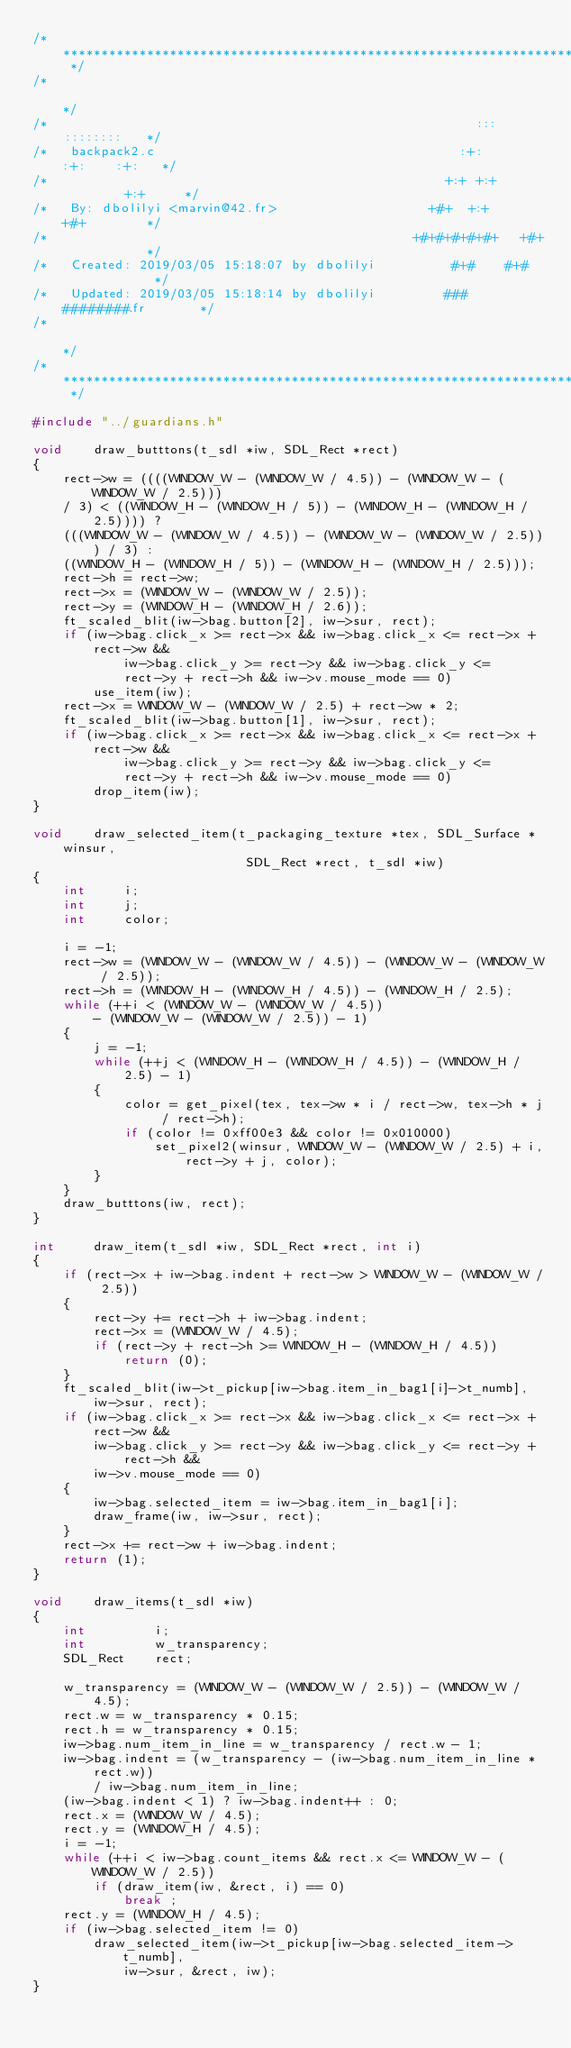<code> <loc_0><loc_0><loc_500><loc_500><_C_>/* ************************************************************************** */
/*                                                                            */
/*                                                        :::      ::::::::   */
/*   backpack2.c                                        :+:      :+:    :+:   */
/*                                                    +:+ +:+         +:+     */
/*   By: dbolilyi <marvin@42.fr>                    +#+  +:+       +#+        */
/*                                                +#+#+#+#+#+   +#+           */
/*   Created: 2019/03/05 15:18:07 by dbolilyi          #+#    #+#             */
/*   Updated: 2019/03/05 15:18:14 by dbolilyi         ###   ########.fr       */
/*                                                                            */
/* ************************************************************************** */

#include "../guardians.h"

void	draw_butttons(t_sdl *iw, SDL_Rect *rect)
{
	rect->w = ((((WINDOW_W - (WINDOW_W / 4.5)) - (WINDOW_W - (WINDOW_W / 2.5)))
	/ 3) < ((WINDOW_H - (WINDOW_H / 5)) - (WINDOW_H - (WINDOW_H / 2.5)))) ?
	(((WINDOW_W - (WINDOW_W / 4.5)) - (WINDOW_W - (WINDOW_W / 2.5))) / 3) :
	((WINDOW_H - (WINDOW_H / 5)) - (WINDOW_H - (WINDOW_H / 2.5)));
	rect->h = rect->w;
	rect->x = (WINDOW_W - (WINDOW_W / 2.5));
	rect->y = (WINDOW_H - (WINDOW_H / 2.6));
	ft_scaled_blit(iw->bag.button[2], iw->sur, rect);
	if (iw->bag.click_x >= rect->x && iw->bag.click_x <= rect->x + rect->w &&
			iw->bag.click_y >= rect->y && iw->bag.click_y <=
			rect->y + rect->h && iw->v.mouse_mode == 0)
		use_item(iw);
	rect->x = WINDOW_W - (WINDOW_W / 2.5) + rect->w * 2;
	ft_scaled_blit(iw->bag.button[1], iw->sur, rect);
	if (iw->bag.click_x >= rect->x && iw->bag.click_x <= rect->x + rect->w &&
			iw->bag.click_y >= rect->y && iw->bag.click_y <=
			rect->y + rect->h && iw->v.mouse_mode == 0)
		drop_item(iw);
}

void	draw_selected_item(t_packaging_texture *tex, SDL_Surface *winsur,
							SDL_Rect *rect, t_sdl *iw)
{
	int		i;
	int		j;
	int		color;

	i = -1;
	rect->w = (WINDOW_W - (WINDOW_W / 4.5)) - (WINDOW_W - (WINDOW_W / 2.5));
	rect->h = (WINDOW_H - (WINDOW_H / 4.5)) - (WINDOW_H / 2.5);
	while (++i < (WINDOW_W - (WINDOW_W / 4.5))
		- (WINDOW_W - (WINDOW_W / 2.5)) - 1)
	{
		j = -1;
		while (++j < (WINDOW_H - (WINDOW_H / 4.5)) - (WINDOW_H / 2.5) - 1)
		{
			color = get_pixel(tex, tex->w * i / rect->w, tex->h * j / rect->h);
			if (color != 0xff00e3 && color != 0x010000)
				set_pixel2(winsur, WINDOW_W - (WINDOW_W / 2.5) + i,
					rect->y + j, color);
		}
	}
	draw_butttons(iw, rect);
}

int		draw_item(t_sdl *iw, SDL_Rect *rect, int i)
{
	if (rect->x + iw->bag.indent + rect->w > WINDOW_W - (WINDOW_W / 2.5))
	{
		rect->y += rect->h + iw->bag.indent;
		rect->x = (WINDOW_W / 4.5);
		if (rect->y + rect->h >= WINDOW_H - (WINDOW_H / 4.5))
			return (0);
	}
	ft_scaled_blit(iw->t_pickup[iw->bag.item_in_bag1[i]->t_numb],
		iw->sur, rect);
	if (iw->bag.click_x >= rect->x && iw->bag.click_x <= rect->x + rect->w &&
		iw->bag.click_y >= rect->y && iw->bag.click_y <= rect->y + rect->h &&
		iw->v.mouse_mode == 0)
	{
		iw->bag.selected_item = iw->bag.item_in_bag1[i];
		draw_frame(iw, iw->sur, rect);
	}
	rect->x += rect->w + iw->bag.indent;
	return (1);
}

void	draw_items(t_sdl *iw)
{
	int			i;
	int			w_transparency;
	SDL_Rect	rect;

	w_transparency = (WINDOW_W - (WINDOW_W / 2.5)) - (WINDOW_W / 4.5);
	rect.w = w_transparency * 0.15;
	rect.h = w_transparency * 0.15;
	iw->bag.num_item_in_line = w_transparency / rect.w - 1;
	iw->bag.indent = (w_transparency - (iw->bag.num_item_in_line * rect.w))
		/ iw->bag.num_item_in_line;
	(iw->bag.indent < 1) ? iw->bag.indent++ : 0;
	rect.x = (WINDOW_W / 4.5);
	rect.y = (WINDOW_H / 4.5);
	i = -1;
	while (++i < iw->bag.count_items && rect.x <= WINDOW_W - (WINDOW_W / 2.5))
		if (draw_item(iw, &rect, i) == 0)
			break ;
	rect.y = (WINDOW_H / 4.5);
	if (iw->bag.selected_item != 0)
		draw_selected_item(iw->t_pickup[iw->bag.selected_item->t_numb],
			iw->sur, &rect, iw);
}
</code> 